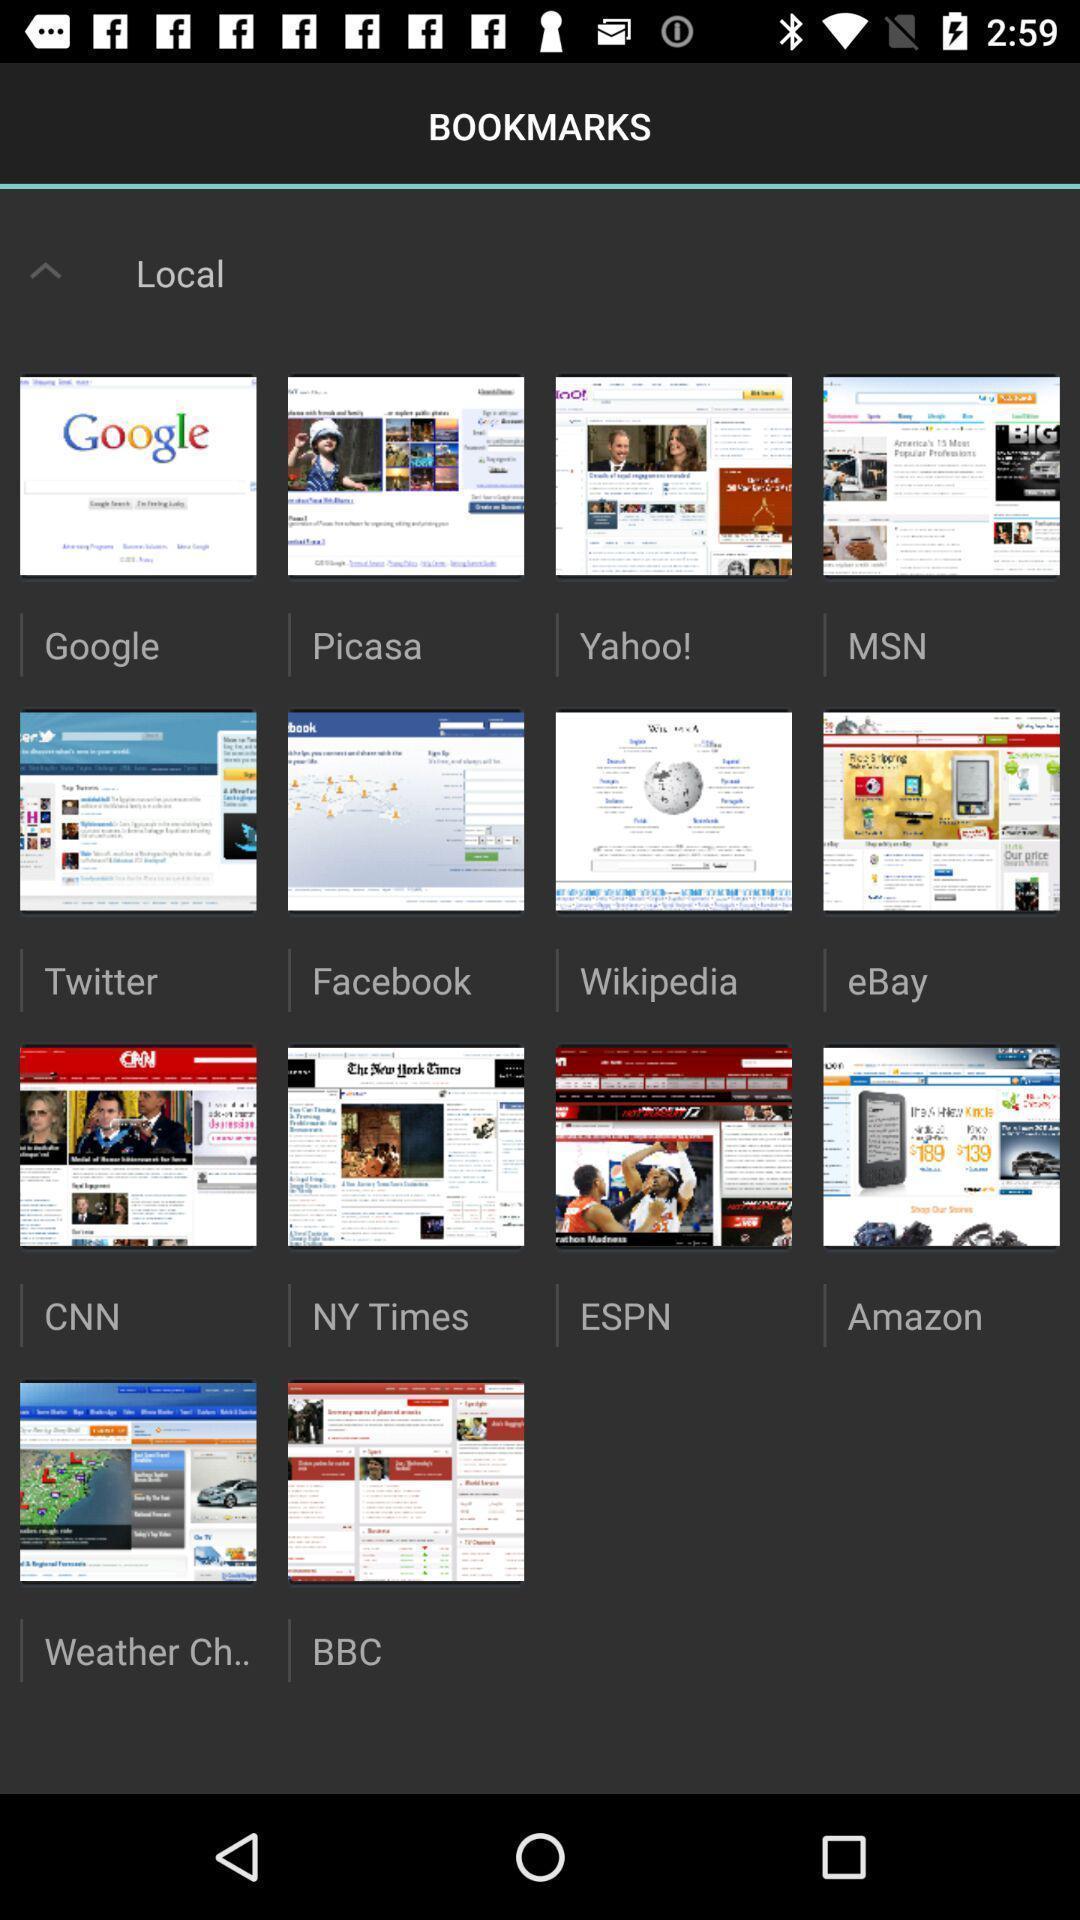Tell me about the visual elements in this screen capture. Screen page displaying different applications. 